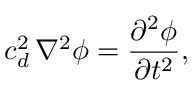<formula> <loc_0><loc_0><loc_500><loc_500>c _ { d } ^ { 2 } \, \nabla ^ { 2 } \phi = \frac { \partial ^ { 2 } \phi } { \partial t ^ { 2 } } ,</formula> 